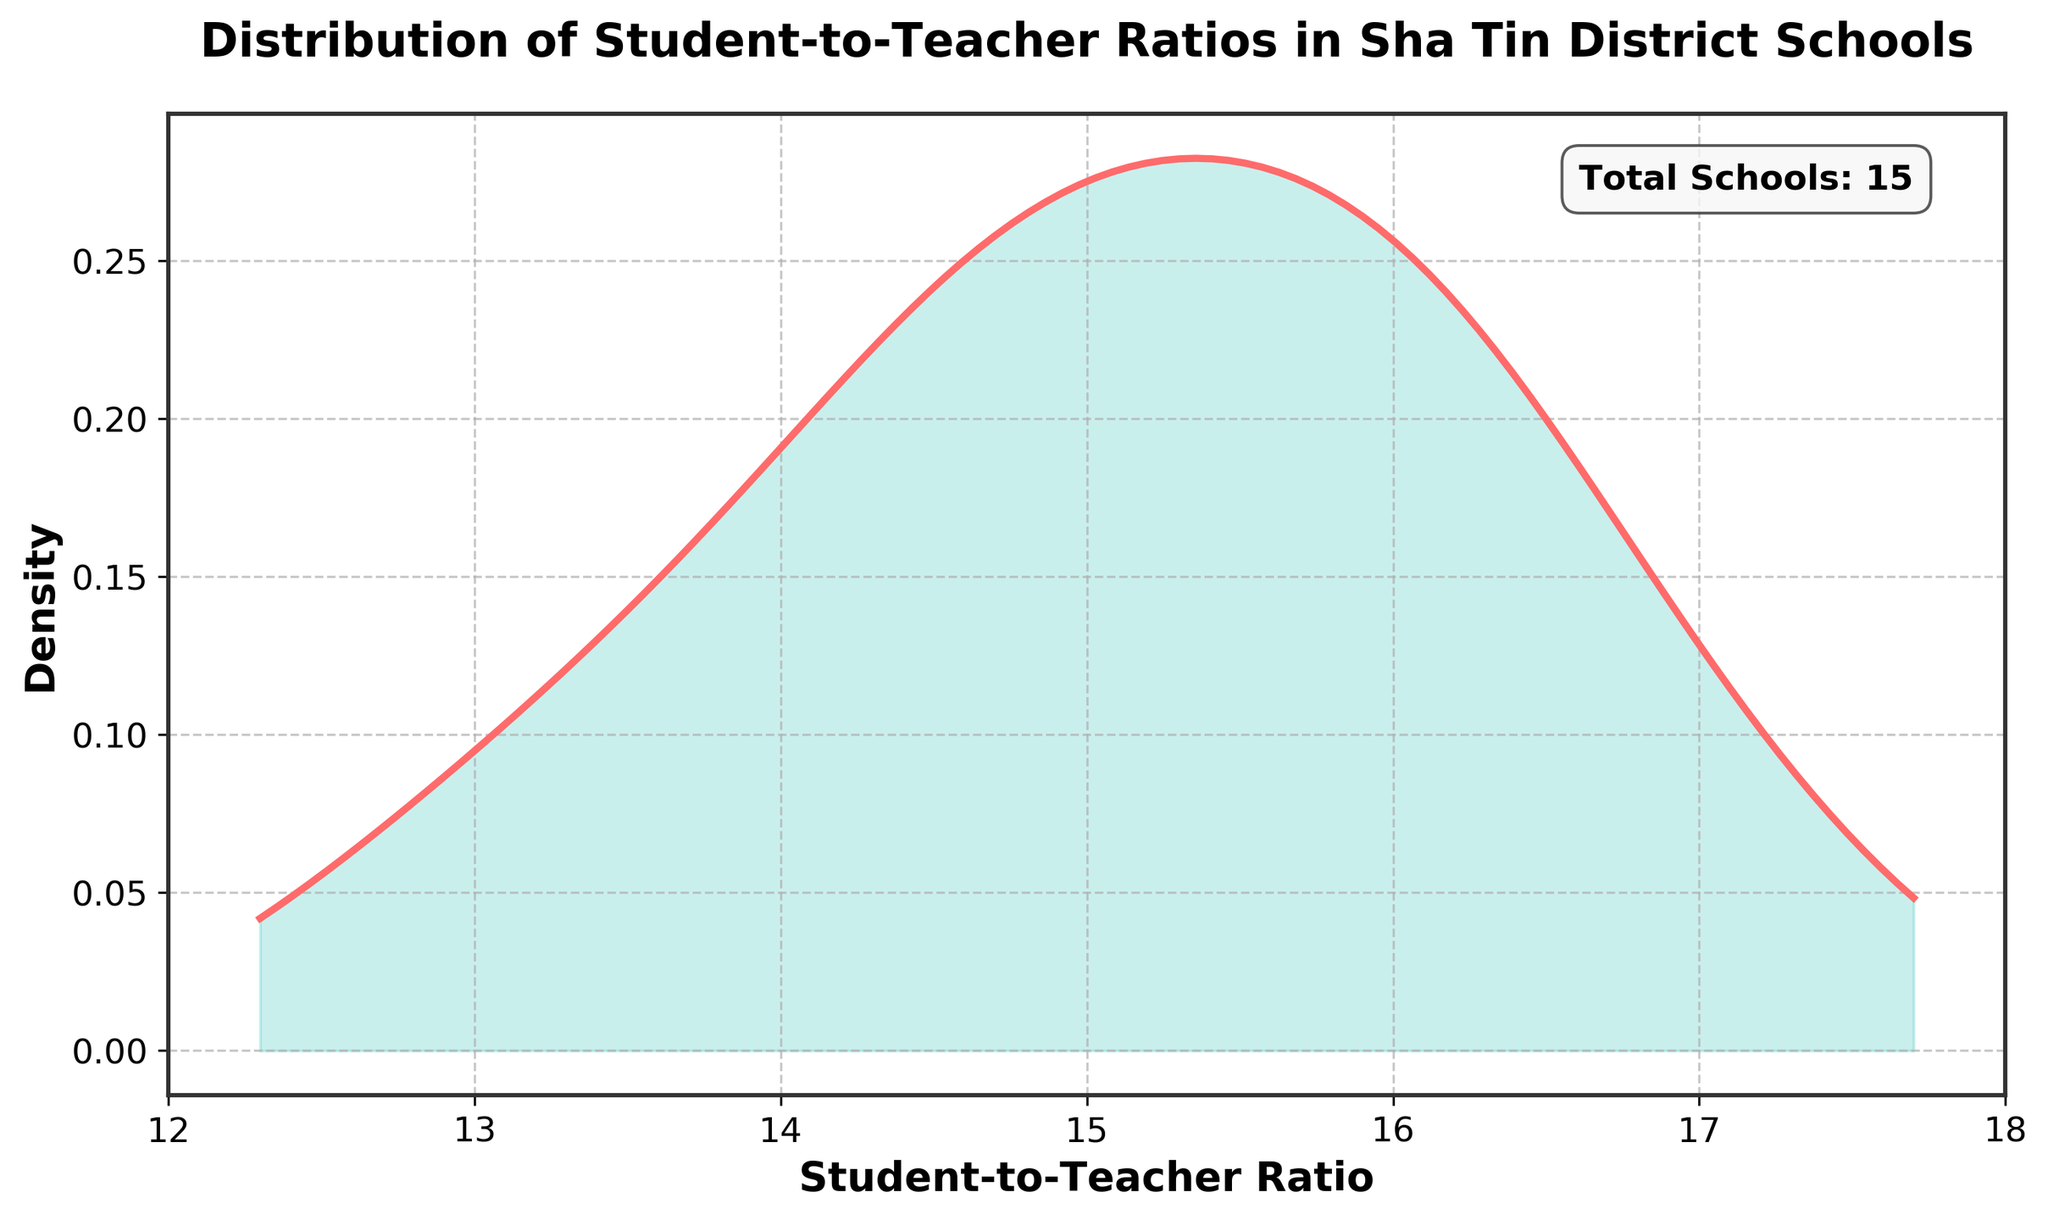What is the title of the figure? The title of the figure is usually displayed at the top. It directly describes what the plot is about.
Answer: Distribution of Student-to-Teacher Ratios in Sha Tin District Schools What do the x-axis and y-axis represent respectively? The x-axis represents the Student-to-Teacher Ratio, and the y-axis represents the Density, which reflects how ratios are distributed across schools.
Answer: Student-to-Teacher Ratio, Density How many schools are included in the plot? The plot mentions the total number of schools in a text box. This information is provided in the upper right corner of the plot.
Answer: 15 What is the range of the x-axis in the plot? The x-axis limits are set and can be seen at the beginning and the end of the x-axis line, indicating the range of Student-to-Teacher Ratios displayed in the plot.
Answer: 12 to 18 Which Student-to-Teacher Ratio appears to be the most frequent based on the density plot? The most frequent value is where the density curve peaks the highest. This point indicates the value with the highest density.
Answer: Around 15 How does the plot highlight the distribution of student-to-teacher ratios? The plot uses a curve filled with color underneath it to represent density over the range of ratios. The height and shape of the curve show the distribution.
Answer: A colored curve What is the approximate student-to-teacher ratio where the density starts to increase significantly? Looking at the x-axis where the density plot starts to rise from near-zero density helps identify this point.
Answer: Around 13 Which school is closest to the peak density of the Student-to-Teacher Ratio? By identifying the peak and matching it to the closest value from the data provided, we find the nearest school.
Answer: Sha Tin Methodist College (approximately 15.2) Is there a clear trend or pattern evident in the student-to-teacher ratios across the schools? Observing the density plot for any obvious trends such as central tendencies around specific values can help assess whether there's a noticeable pattern.
Answer: Centered around 14-16 Is the distribution of student-to-teacher ratios positively or negatively skewed, and how can you tell? By examining the shape of the density plot, especially the tails, one can determine the skewness. A right tail suggests positive skewness, and a left tail suggests negative skewness.
Answer: Slightly positive skew 